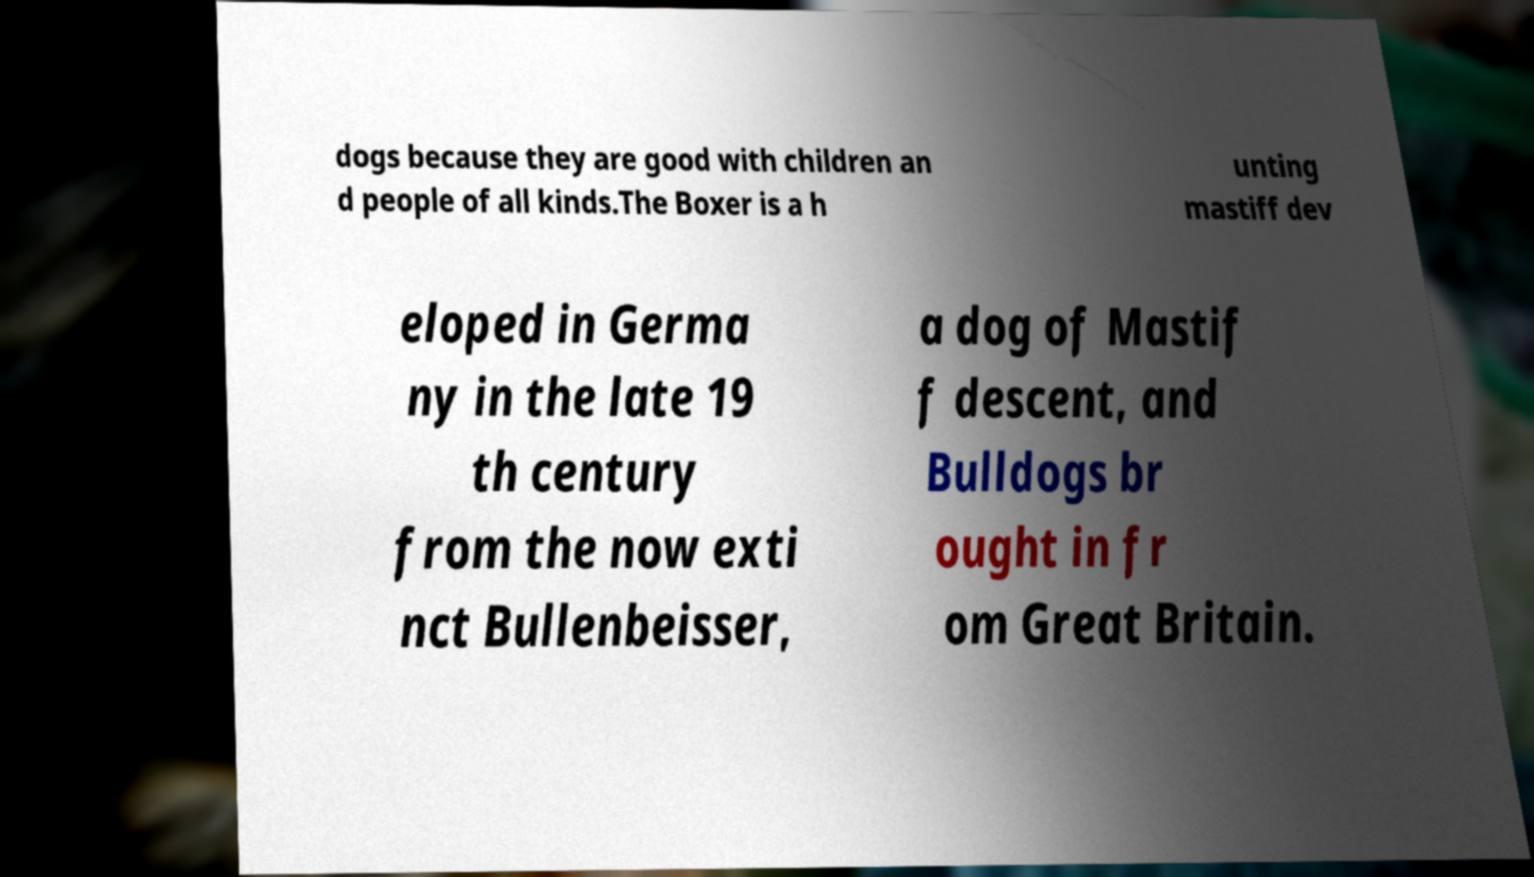Please read and relay the text visible in this image. What does it say? dogs because they are good with children an d people of all kinds.The Boxer is a h unting mastiff dev eloped in Germa ny in the late 19 th century from the now exti nct Bullenbeisser, a dog of Mastif f descent, and Bulldogs br ought in fr om Great Britain. 